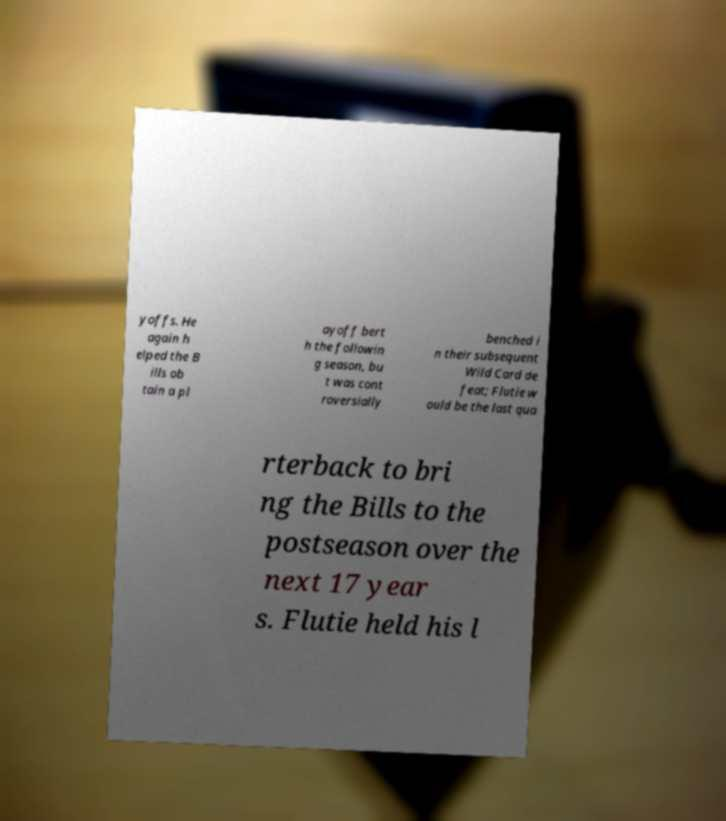I need the written content from this picture converted into text. Can you do that? yoffs. He again h elped the B ills ob tain a pl ayoff bert h the followin g season, bu t was cont roversially benched i n their subsequent Wild Card de feat; Flutie w ould be the last qua rterback to bri ng the Bills to the postseason over the next 17 year s. Flutie held his l 